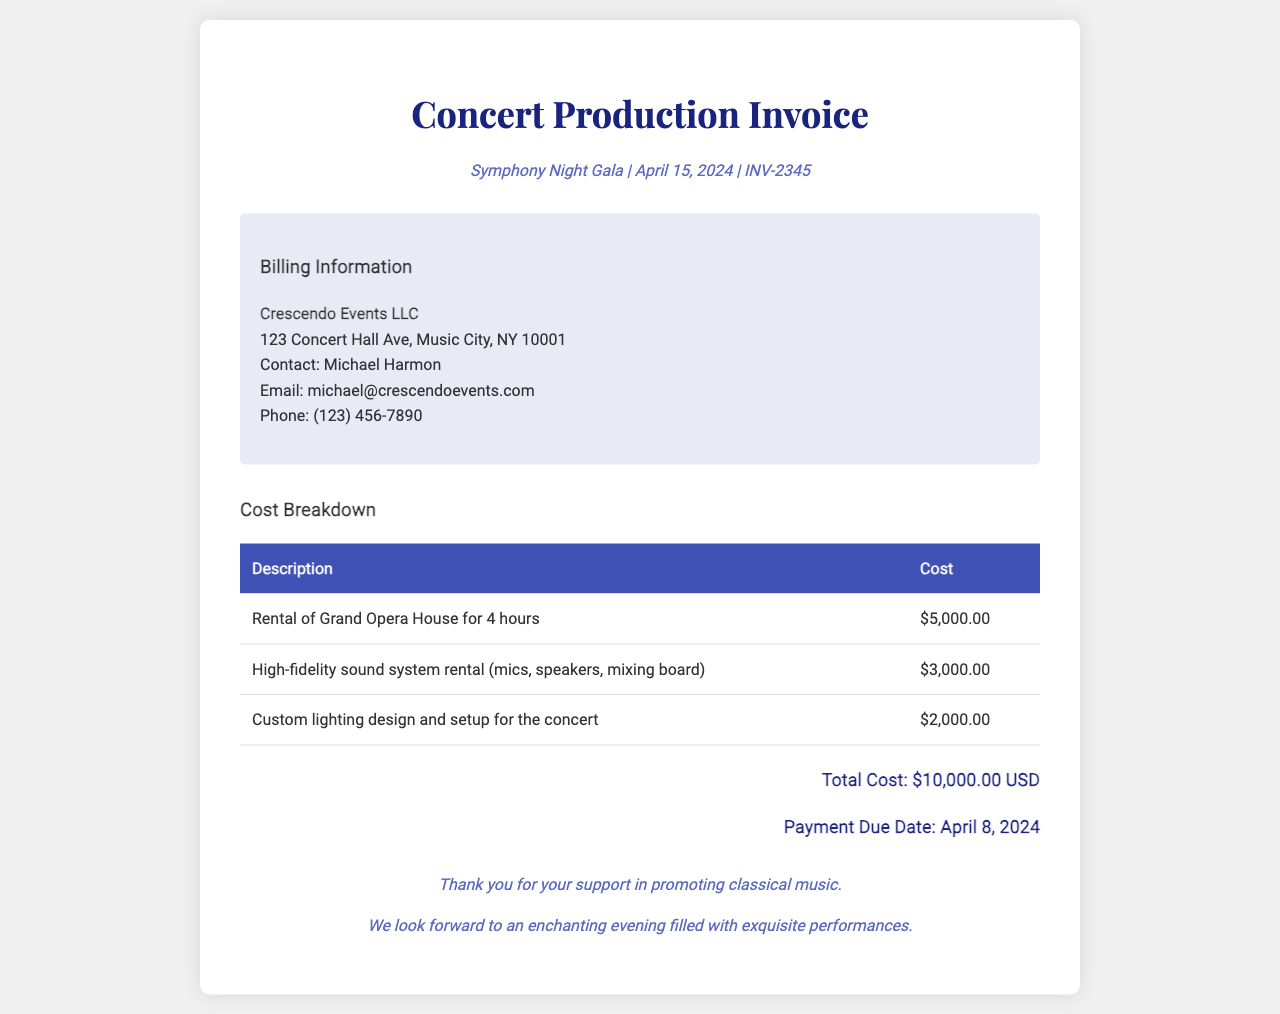What is the title of the event? The title of the event is mentioned in the header as "Symphony Night Gala".
Answer: Symphony Night Gala What is the total cost of the concert production? The total cost is clearly stated in the cost breakdown section of the document.
Answer: $10,000.00 USD Who is the contact person for Crescendo Events LLC? The document indicates the contact person under the billing information section.
Answer: Michael Harmon When is the payment due date? The due date for the payment is specified in the total cost section of the document.
Answer: April 8, 2024 How long is the rental for the Grand Opera House? The rental duration is specified in the cost breakdown under the description of the venue rental.
Answer: 4 hours What type of sound system is rented for the concert? The specifics of the sound system rental are listed in the cost breakdown.
Answer: High-fidelity sound system What is included in the lighting design cost? The description of the lighting cost denotes what it entails.
Answer: Custom lighting design and setup What is the address of Crescendo Events LLC? The address is provided in the billing information section of the invoice.
Answer: 123 Concert Hall Ave, Music City, NY 10001 What is the cost of the sound equipment? The document specifies the cost of the sound equipment in the cost breakdown section.
Answer: $3,000.00 